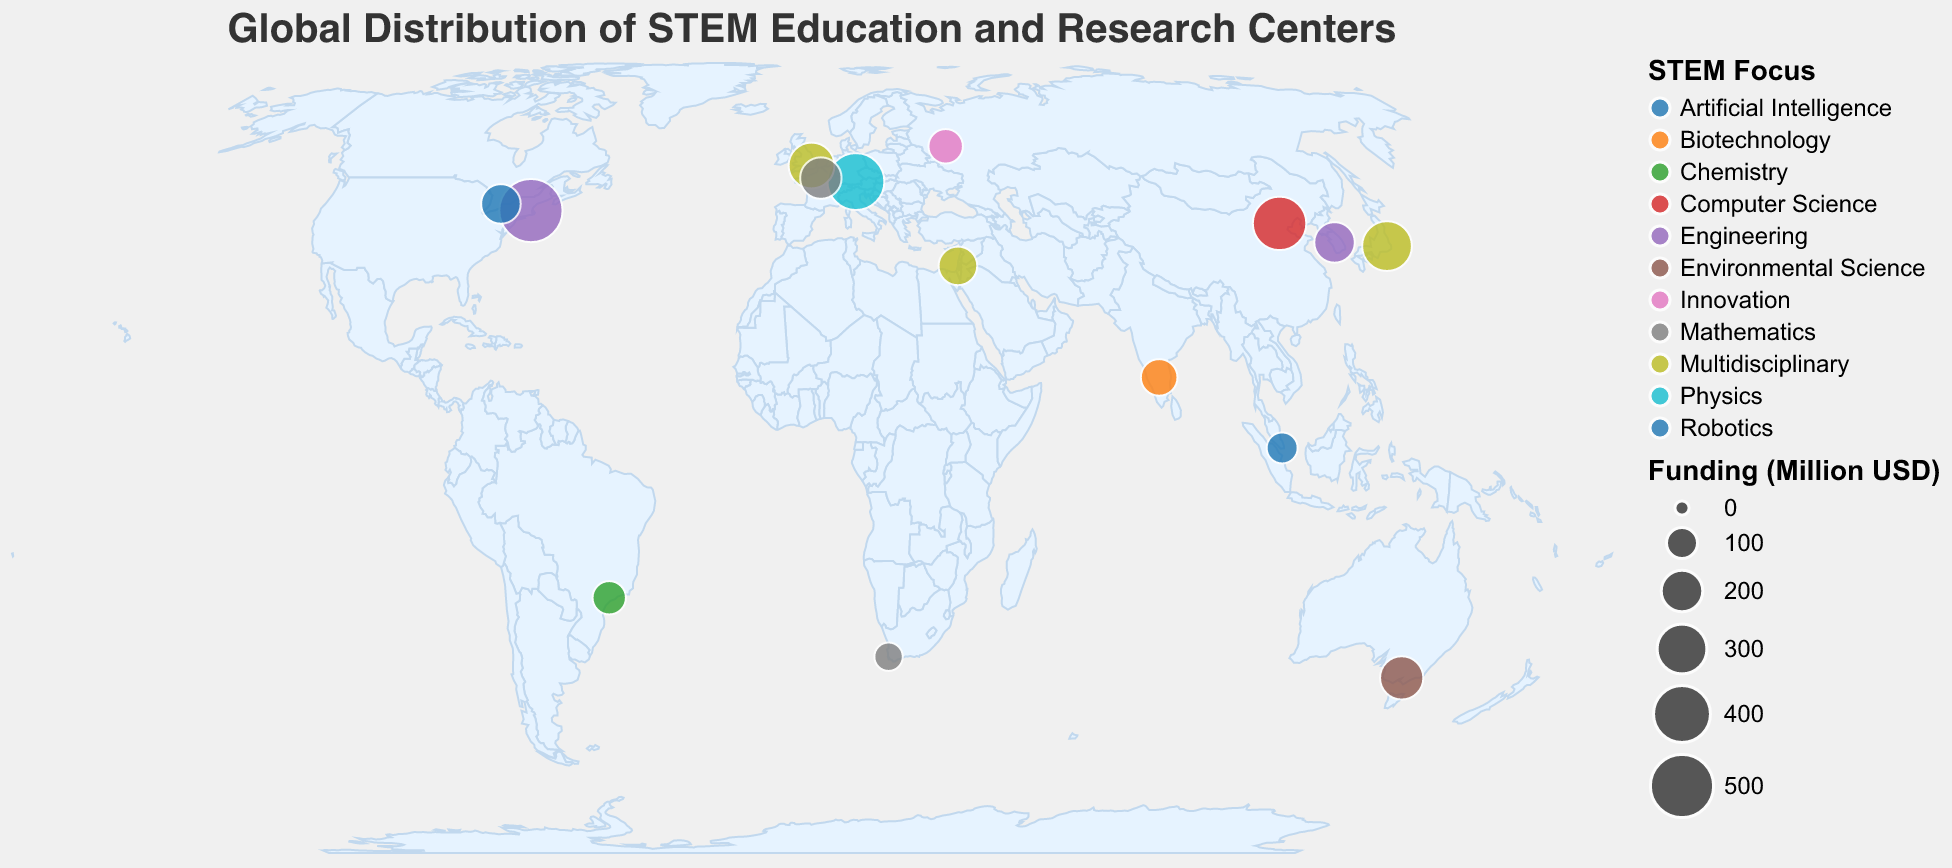What's the largest funding for any institution displayed on the map? The size of the circles represents the funding in million USD. The largest circle corresponds to the Massachusetts Institute of Technology in the United States with a funding of 500 million USD.
Answer: 500 million USD How many institutions in the map have a STEM focus on Mathematics? By observing the legends and colors representing different STEM focuses, we can see that there are two institutions focused on Mathematics: École Polytechnique in France and the African Institute for Mathematical Sciences in South Africa.
Answer: 2 Which country has the highest concentration of research centers based on their size on the map? The circles' size and density indicate the concentration of research centers. The United States, with the largest circle for the Massachusetts Institute of Technology, shows the highest concentration by funding alone.
Answer: United States What is the total funding for institutions in Europe? By identifying the European institutions: Max Planck Society in Germany (400), Imperial College London in the United Kingdom (250), and École Polytechnique in France (200), summing their funding amounts gives us 400 + 250 + 200 = 850 million USD.
Answer: 850 million USD Which institution focuses on Artificial Intelligence and where is it located? By looking at the legend for STEM Focus and the tooltip information, we find that the University of Toronto in Canada focuses on Artificial Intelligence.
Answer: University of Toronto, Canada What is the total number of institutions present on the map? Counting each institution mentioned in the tooltips or data points, we find there are 15 institutions.
Answer: 15 Compare the funding between KAIST in South Korea and Tsinghua University in China. Which one has more funding and by how much? The funding for KAIST is 190 million USD, and for Tsinghua University, it is 350 million USD. The difference is 350 - 190 = 160 million USD. Therefore, Tsinghua University has 160 million USD more funding than KAIST.
Answer: Tsinghua University, by 160 million USD What type of institution is located in Singapore, and what is its STEM focus? By looking at the circle for Singapore and the tooltip information, we see that it is an Education Initiative focusing on Robotics.
Answer: Education Initiative, Robotics Which institution on the map has the smallest funding and what is its focus? The smallest circle corresponds to the African Institute for Mathematical Sciences in South Africa, which focuses on Mathematics, with a funding of 80 million USD.
Answer: African Institute for Mathematical Sciences, Mathematics How many multidisciplinary-focused institutions are displayed on the map? By examining the color legend and tooltips, identifying the institutions with a multidisciplinary focus includes RIKEN in Japan, Imperial College London in the United Kingdom, and the Weizmann Institute of Science in Israel. There are 3 such institutions.
Answer: 3 